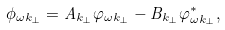<formula> <loc_0><loc_0><loc_500><loc_500>\phi _ { \omega { k } _ { \perp } } = A _ { { k } _ { \perp } } \varphi _ { \omega { k } _ { \perp } } - B _ { { k } _ { \perp } } \varphi _ { \omega { k } _ { \perp } } ^ { * } ,</formula> 